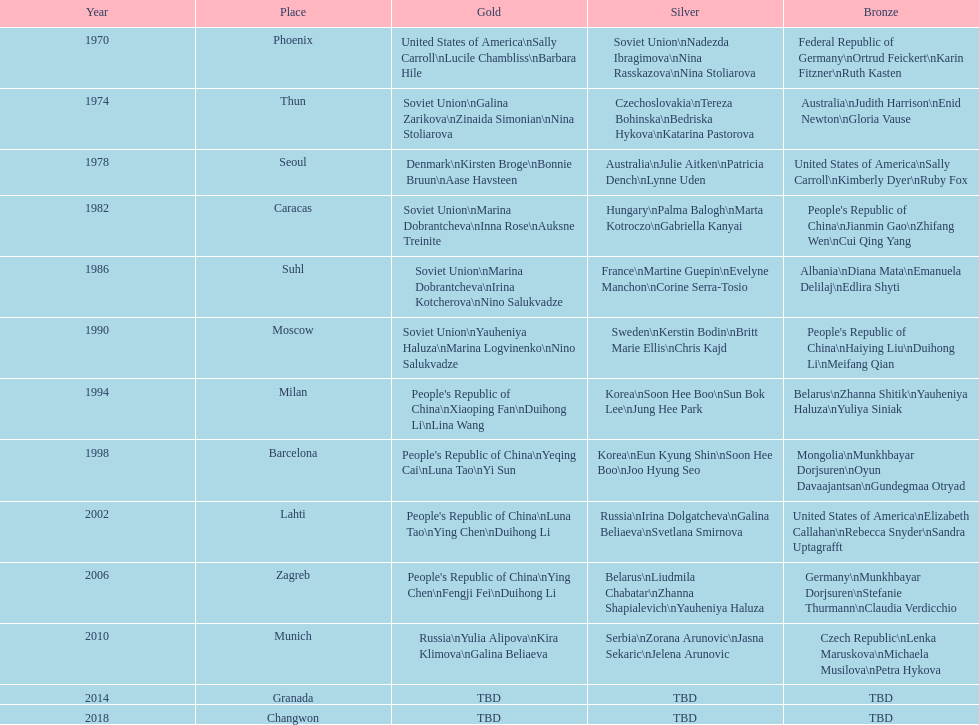I'm looking to parse the entire table for insights. Could you assist me with that? {'header': ['Year', 'Place', 'Gold', 'Silver', 'Bronze'], 'rows': [['1970', 'Phoenix', 'United States of America\\nSally Carroll\\nLucile Chambliss\\nBarbara Hile', 'Soviet Union\\nNadezda Ibragimova\\nNina Rasskazova\\nNina Stoliarova', 'Federal Republic of Germany\\nOrtrud Feickert\\nKarin Fitzner\\nRuth Kasten'], ['1974', 'Thun', 'Soviet Union\\nGalina Zarikova\\nZinaida Simonian\\nNina Stoliarova', 'Czechoslovakia\\nTereza Bohinska\\nBedriska Hykova\\nKatarina Pastorova', 'Australia\\nJudith Harrison\\nEnid Newton\\nGloria Vause'], ['1978', 'Seoul', 'Denmark\\nKirsten Broge\\nBonnie Bruun\\nAase Havsteen', 'Australia\\nJulie Aitken\\nPatricia Dench\\nLynne Uden', 'United States of America\\nSally Carroll\\nKimberly Dyer\\nRuby Fox'], ['1982', 'Caracas', 'Soviet Union\\nMarina Dobrantcheva\\nInna Rose\\nAuksne Treinite', 'Hungary\\nPalma Balogh\\nMarta Kotroczo\\nGabriella Kanyai', "People's Republic of China\\nJianmin Gao\\nZhifang Wen\\nCui Qing Yang"], ['1986', 'Suhl', 'Soviet Union\\nMarina Dobrantcheva\\nIrina Kotcherova\\nNino Salukvadze', 'France\\nMartine Guepin\\nEvelyne Manchon\\nCorine Serra-Tosio', 'Albania\\nDiana Mata\\nEmanuela Delilaj\\nEdlira Shyti'], ['1990', 'Moscow', 'Soviet Union\\nYauheniya Haluza\\nMarina Logvinenko\\nNino Salukvadze', 'Sweden\\nKerstin Bodin\\nBritt Marie Ellis\\nChris Kajd', "People's Republic of China\\nHaiying Liu\\nDuihong Li\\nMeifang Qian"], ['1994', 'Milan', "People's Republic of China\\nXiaoping Fan\\nDuihong Li\\nLina Wang", 'Korea\\nSoon Hee Boo\\nSun Bok Lee\\nJung Hee Park', 'Belarus\\nZhanna Shitik\\nYauheniya Haluza\\nYuliya Siniak'], ['1998', 'Barcelona', "People's Republic of China\\nYeqing Cai\\nLuna Tao\\nYi Sun", 'Korea\\nEun Kyung Shin\\nSoon Hee Boo\\nJoo Hyung Seo', 'Mongolia\\nMunkhbayar Dorjsuren\\nOyun Davaajantsan\\nGundegmaa Otryad'], ['2002', 'Lahti', "People's Republic of China\\nLuna Tao\\nYing Chen\\nDuihong Li", 'Russia\\nIrina Dolgatcheva\\nGalina Beliaeva\\nSvetlana Smirnova', 'United States of America\\nElizabeth Callahan\\nRebecca Snyder\\nSandra Uptagrafft'], ['2006', 'Zagreb', "People's Republic of China\\nYing Chen\\nFengji Fei\\nDuihong Li", 'Belarus\\nLiudmila Chabatar\\nZhanna Shapialevich\\nYauheniya Haluza', 'Germany\\nMunkhbayar Dorjsuren\\nStefanie Thurmann\\nClaudia Verdicchio'], ['2010', 'Munich', 'Russia\\nYulia Alipova\\nKira Klimova\\nGalina Beliaeva', 'Serbia\\nZorana Arunovic\\nJasna Sekaric\\nJelena Arunovic', 'Czech Republic\\nLenka Maruskova\\nMichaela Musilova\\nPetra Hykova'], ['2014', 'Granada', 'TBD', 'TBD', 'TBD'], ['2018', 'Changwon', 'TBD', 'TBD', 'TBD']]} What is the cumulative number of instances where the soviet union is mentioned in the gold column? 4. 